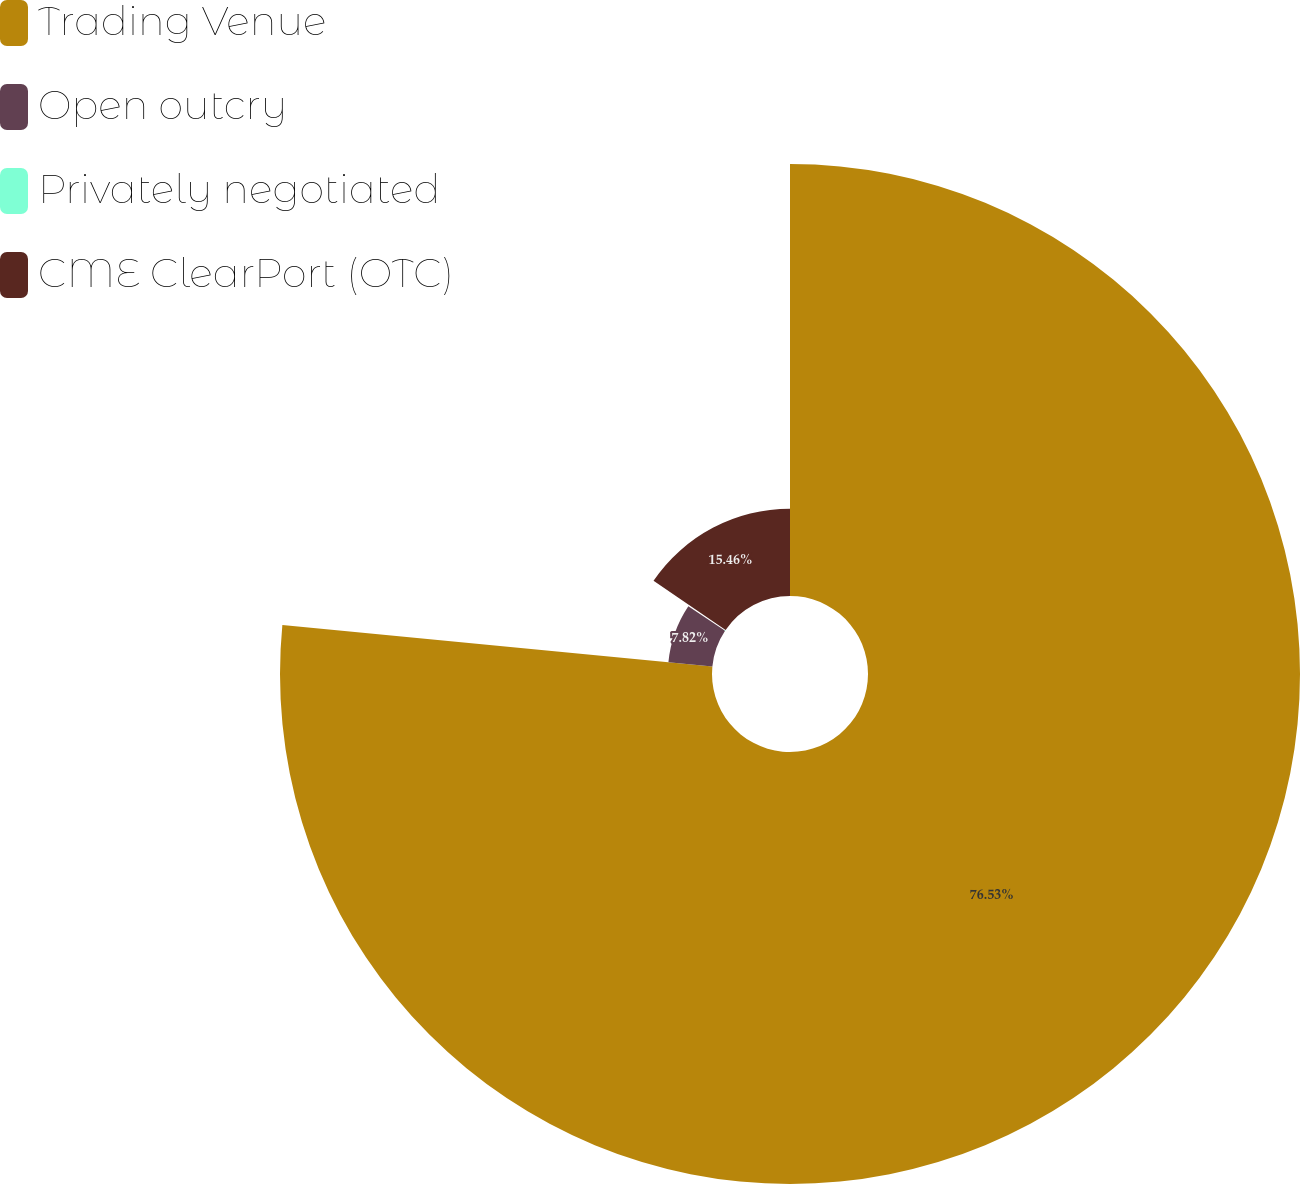<chart> <loc_0><loc_0><loc_500><loc_500><pie_chart><fcel>Trading Venue<fcel>Open outcry<fcel>Privately negotiated<fcel>CME ClearPort (OTC)<nl><fcel>76.53%<fcel>7.82%<fcel>0.19%<fcel>15.46%<nl></chart> 